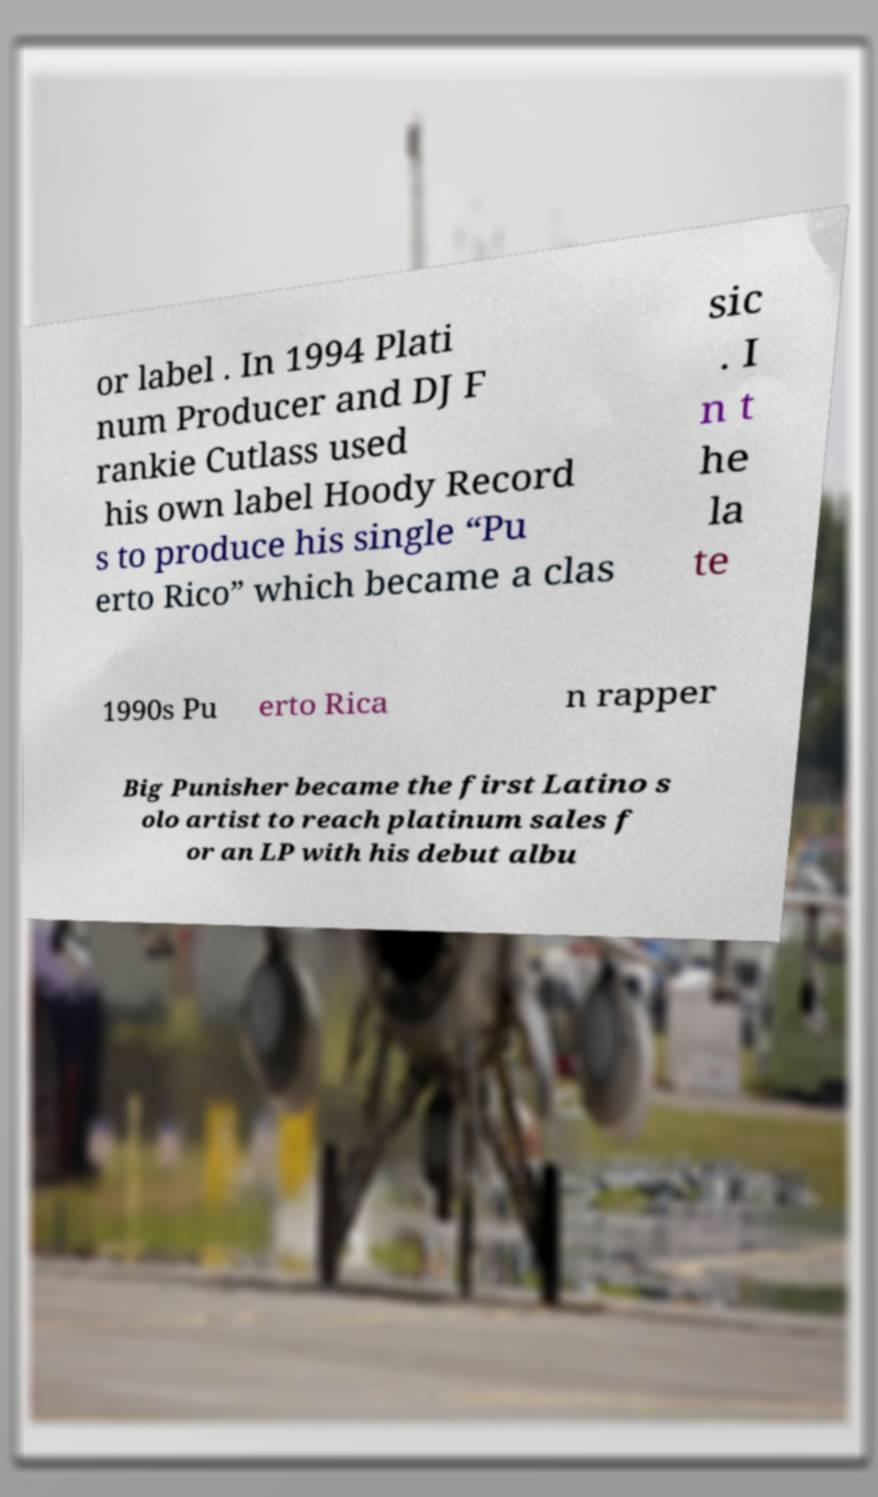Could you extract and type out the text from this image? or label . In 1994 Plati num Producer and DJ F rankie Cutlass used his own label Hoody Record s to produce his single “Pu erto Rico” which became a clas sic . I n t he la te 1990s Pu erto Rica n rapper Big Punisher became the first Latino s olo artist to reach platinum sales f or an LP with his debut albu 